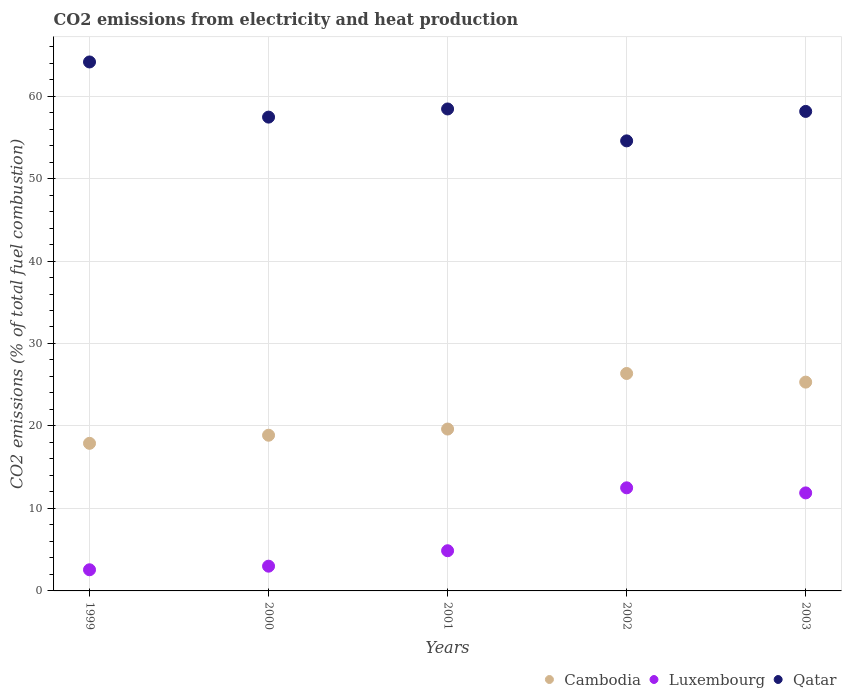How many different coloured dotlines are there?
Your answer should be compact. 3. Is the number of dotlines equal to the number of legend labels?
Offer a terse response. Yes. What is the amount of CO2 emitted in Luxembourg in 2000?
Your answer should be very brief. 3. Across all years, what is the maximum amount of CO2 emitted in Qatar?
Offer a terse response. 64.13. Across all years, what is the minimum amount of CO2 emitted in Cambodia?
Your answer should be very brief. 17.89. In which year was the amount of CO2 emitted in Luxembourg minimum?
Ensure brevity in your answer.  1999. What is the total amount of CO2 emitted in Luxembourg in the graph?
Your answer should be compact. 34.82. What is the difference between the amount of CO2 emitted in Cambodia in 1999 and that in 2000?
Provide a succinct answer. -0.98. What is the difference between the amount of CO2 emitted in Qatar in 2002 and the amount of CO2 emitted in Luxembourg in 2003?
Provide a succinct answer. 42.68. What is the average amount of CO2 emitted in Cambodia per year?
Offer a very short reply. 21.62. In the year 2002, what is the difference between the amount of CO2 emitted in Luxembourg and amount of CO2 emitted in Qatar?
Your response must be concise. -42.07. In how many years, is the amount of CO2 emitted in Cambodia greater than 2 %?
Offer a very short reply. 5. What is the ratio of the amount of CO2 emitted in Qatar in 2001 to that in 2002?
Your response must be concise. 1.07. Is the amount of CO2 emitted in Cambodia in 2001 less than that in 2002?
Your answer should be very brief. Yes. What is the difference between the highest and the second highest amount of CO2 emitted in Cambodia?
Keep it short and to the point. 1.05. What is the difference between the highest and the lowest amount of CO2 emitted in Cambodia?
Make the answer very short. 8.47. Is the amount of CO2 emitted in Luxembourg strictly greater than the amount of CO2 emitted in Cambodia over the years?
Ensure brevity in your answer.  No. How many dotlines are there?
Make the answer very short. 3. What is the difference between two consecutive major ticks on the Y-axis?
Provide a short and direct response. 10. Are the values on the major ticks of Y-axis written in scientific E-notation?
Keep it short and to the point. No. What is the title of the graph?
Give a very brief answer. CO2 emissions from electricity and heat production. Does "Upper middle income" appear as one of the legend labels in the graph?
Make the answer very short. No. What is the label or title of the Y-axis?
Offer a terse response. CO2 emissions (% of total fuel combustion). What is the CO2 emissions (% of total fuel combustion) in Cambodia in 1999?
Offer a very short reply. 17.89. What is the CO2 emissions (% of total fuel combustion) in Luxembourg in 1999?
Your answer should be very brief. 2.56. What is the CO2 emissions (% of total fuel combustion) in Qatar in 1999?
Offer a terse response. 64.13. What is the CO2 emissions (% of total fuel combustion) of Cambodia in 2000?
Your answer should be compact. 18.88. What is the CO2 emissions (% of total fuel combustion) of Qatar in 2000?
Ensure brevity in your answer.  57.45. What is the CO2 emissions (% of total fuel combustion) in Cambodia in 2001?
Keep it short and to the point. 19.63. What is the CO2 emissions (% of total fuel combustion) in Luxembourg in 2001?
Provide a succinct answer. 4.87. What is the CO2 emissions (% of total fuel combustion) of Qatar in 2001?
Provide a short and direct response. 58.44. What is the CO2 emissions (% of total fuel combustion) of Cambodia in 2002?
Your response must be concise. 26.36. What is the CO2 emissions (% of total fuel combustion) of Luxembourg in 2002?
Ensure brevity in your answer.  12.5. What is the CO2 emissions (% of total fuel combustion) of Qatar in 2002?
Keep it short and to the point. 54.57. What is the CO2 emissions (% of total fuel combustion) in Cambodia in 2003?
Your answer should be very brief. 25.32. What is the CO2 emissions (% of total fuel combustion) in Luxembourg in 2003?
Ensure brevity in your answer.  11.89. What is the CO2 emissions (% of total fuel combustion) of Qatar in 2003?
Offer a very short reply. 58.14. Across all years, what is the maximum CO2 emissions (% of total fuel combustion) in Cambodia?
Make the answer very short. 26.36. Across all years, what is the maximum CO2 emissions (% of total fuel combustion) in Luxembourg?
Offer a very short reply. 12.5. Across all years, what is the maximum CO2 emissions (% of total fuel combustion) of Qatar?
Provide a succinct answer. 64.13. Across all years, what is the minimum CO2 emissions (% of total fuel combustion) of Cambodia?
Offer a terse response. 17.89. Across all years, what is the minimum CO2 emissions (% of total fuel combustion) of Luxembourg?
Make the answer very short. 2.56. Across all years, what is the minimum CO2 emissions (% of total fuel combustion) of Qatar?
Offer a very short reply. 54.57. What is the total CO2 emissions (% of total fuel combustion) in Cambodia in the graph?
Provide a succinct answer. 108.08. What is the total CO2 emissions (% of total fuel combustion) of Luxembourg in the graph?
Provide a succinct answer. 34.82. What is the total CO2 emissions (% of total fuel combustion) in Qatar in the graph?
Provide a succinct answer. 292.72. What is the difference between the CO2 emissions (% of total fuel combustion) in Cambodia in 1999 and that in 2000?
Provide a short and direct response. -0.98. What is the difference between the CO2 emissions (% of total fuel combustion) of Luxembourg in 1999 and that in 2000?
Offer a very short reply. -0.44. What is the difference between the CO2 emissions (% of total fuel combustion) of Qatar in 1999 and that in 2000?
Your answer should be very brief. 6.69. What is the difference between the CO2 emissions (% of total fuel combustion) in Cambodia in 1999 and that in 2001?
Your answer should be very brief. -1.73. What is the difference between the CO2 emissions (% of total fuel combustion) in Luxembourg in 1999 and that in 2001?
Your response must be concise. -2.31. What is the difference between the CO2 emissions (% of total fuel combustion) in Qatar in 1999 and that in 2001?
Provide a short and direct response. 5.7. What is the difference between the CO2 emissions (% of total fuel combustion) of Cambodia in 1999 and that in 2002?
Make the answer very short. -8.47. What is the difference between the CO2 emissions (% of total fuel combustion) in Luxembourg in 1999 and that in 2002?
Offer a very short reply. -9.94. What is the difference between the CO2 emissions (% of total fuel combustion) of Qatar in 1999 and that in 2002?
Offer a very short reply. 9.57. What is the difference between the CO2 emissions (% of total fuel combustion) in Cambodia in 1999 and that in 2003?
Keep it short and to the point. -7.42. What is the difference between the CO2 emissions (% of total fuel combustion) in Luxembourg in 1999 and that in 2003?
Ensure brevity in your answer.  -9.32. What is the difference between the CO2 emissions (% of total fuel combustion) of Qatar in 1999 and that in 2003?
Your response must be concise. 6. What is the difference between the CO2 emissions (% of total fuel combustion) in Cambodia in 2000 and that in 2001?
Your answer should be very brief. -0.75. What is the difference between the CO2 emissions (% of total fuel combustion) of Luxembourg in 2000 and that in 2001?
Give a very brief answer. -1.87. What is the difference between the CO2 emissions (% of total fuel combustion) in Qatar in 2000 and that in 2001?
Your answer should be compact. -0.99. What is the difference between the CO2 emissions (% of total fuel combustion) of Cambodia in 2000 and that in 2002?
Provide a short and direct response. -7.49. What is the difference between the CO2 emissions (% of total fuel combustion) in Luxembourg in 2000 and that in 2002?
Your response must be concise. -9.5. What is the difference between the CO2 emissions (% of total fuel combustion) in Qatar in 2000 and that in 2002?
Your answer should be very brief. 2.88. What is the difference between the CO2 emissions (% of total fuel combustion) in Cambodia in 2000 and that in 2003?
Offer a terse response. -6.44. What is the difference between the CO2 emissions (% of total fuel combustion) in Luxembourg in 2000 and that in 2003?
Offer a terse response. -8.89. What is the difference between the CO2 emissions (% of total fuel combustion) in Qatar in 2000 and that in 2003?
Provide a short and direct response. -0.69. What is the difference between the CO2 emissions (% of total fuel combustion) of Cambodia in 2001 and that in 2002?
Your response must be concise. -6.74. What is the difference between the CO2 emissions (% of total fuel combustion) of Luxembourg in 2001 and that in 2002?
Give a very brief answer. -7.63. What is the difference between the CO2 emissions (% of total fuel combustion) of Qatar in 2001 and that in 2002?
Ensure brevity in your answer.  3.87. What is the difference between the CO2 emissions (% of total fuel combustion) in Cambodia in 2001 and that in 2003?
Keep it short and to the point. -5.69. What is the difference between the CO2 emissions (% of total fuel combustion) in Luxembourg in 2001 and that in 2003?
Offer a very short reply. -7.01. What is the difference between the CO2 emissions (% of total fuel combustion) of Qatar in 2001 and that in 2003?
Give a very brief answer. 0.3. What is the difference between the CO2 emissions (% of total fuel combustion) in Cambodia in 2002 and that in 2003?
Provide a succinct answer. 1.05. What is the difference between the CO2 emissions (% of total fuel combustion) of Luxembourg in 2002 and that in 2003?
Give a very brief answer. 0.61. What is the difference between the CO2 emissions (% of total fuel combustion) of Qatar in 2002 and that in 2003?
Provide a short and direct response. -3.57. What is the difference between the CO2 emissions (% of total fuel combustion) in Cambodia in 1999 and the CO2 emissions (% of total fuel combustion) in Luxembourg in 2000?
Provide a short and direct response. 14.89. What is the difference between the CO2 emissions (% of total fuel combustion) in Cambodia in 1999 and the CO2 emissions (% of total fuel combustion) in Qatar in 2000?
Offer a terse response. -39.55. What is the difference between the CO2 emissions (% of total fuel combustion) in Luxembourg in 1999 and the CO2 emissions (% of total fuel combustion) in Qatar in 2000?
Provide a short and direct response. -54.88. What is the difference between the CO2 emissions (% of total fuel combustion) in Cambodia in 1999 and the CO2 emissions (% of total fuel combustion) in Luxembourg in 2001?
Keep it short and to the point. 13.02. What is the difference between the CO2 emissions (% of total fuel combustion) of Cambodia in 1999 and the CO2 emissions (% of total fuel combustion) of Qatar in 2001?
Provide a short and direct response. -40.54. What is the difference between the CO2 emissions (% of total fuel combustion) of Luxembourg in 1999 and the CO2 emissions (% of total fuel combustion) of Qatar in 2001?
Provide a short and direct response. -55.87. What is the difference between the CO2 emissions (% of total fuel combustion) of Cambodia in 1999 and the CO2 emissions (% of total fuel combustion) of Luxembourg in 2002?
Give a very brief answer. 5.39. What is the difference between the CO2 emissions (% of total fuel combustion) of Cambodia in 1999 and the CO2 emissions (% of total fuel combustion) of Qatar in 2002?
Your answer should be compact. -36.67. What is the difference between the CO2 emissions (% of total fuel combustion) of Luxembourg in 1999 and the CO2 emissions (% of total fuel combustion) of Qatar in 2002?
Provide a short and direct response. -52. What is the difference between the CO2 emissions (% of total fuel combustion) in Cambodia in 1999 and the CO2 emissions (% of total fuel combustion) in Luxembourg in 2003?
Offer a very short reply. 6.01. What is the difference between the CO2 emissions (% of total fuel combustion) of Cambodia in 1999 and the CO2 emissions (% of total fuel combustion) of Qatar in 2003?
Your response must be concise. -40.24. What is the difference between the CO2 emissions (% of total fuel combustion) in Luxembourg in 1999 and the CO2 emissions (% of total fuel combustion) in Qatar in 2003?
Offer a very short reply. -55.57. What is the difference between the CO2 emissions (% of total fuel combustion) of Cambodia in 2000 and the CO2 emissions (% of total fuel combustion) of Luxembourg in 2001?
Ensure brevity in your answer.  14.01. What is the difference between the CO2 emissions (% of total fuel combustion) in Cambodia in 2000 and the CO2 emissions (% of total fuel combustion) in Qatar in 2001?
Your answer should be very brief. -39.56. What is the difference between the CO2 emissions (% of total fuel combustion) in Luxembourg in 2000 and the CO2 emissions (% of total fuel combustion) in Qatar in 2001?
Your response must be concise. -55.44. What is the difference between the CO2 emissions (% of total fuel combustion) of Cambodia in 2000 and the CO2 emissions (% of total fuel combustion) of Luxembourg in 2002?
Your response must be concise. 6.38. What is the difference between the CO2 emissions (% of total fuel combustion) in Cambodia in 2000 and the CO2 emissions (% of total fuel combustion) in Qatar in 2002?
Your answer should be compact. -35.69. What is the difference between the CO2 emissions (% of total fuel combustion) of Luxembourg in 2000 and the CO2 emissions (% of total fuel combustion) of Qatar in 2002?
Your answer should be very brief. -51.57. What is the difference between the CO2 emissions (% of total fuel combustion) of Cambodia in 2000 and the CO2 emissions (% of total fuel combustion) of Luxembourg in 2003?
Your response must be concise. 6.99. What is the difference between the CO2 emissions (% of total fuel combustion) in Cambodia in 2000 and the CO2 emissions (% of total fuel combustion) in Qatar in 2003?
Give a very brief answer. -39.26. What is the difference between the CO2 emissions (% of total fuel combustion) in Luxembourg in 2000 and the CO2 emissions (% of total fuel combustion) in Qatar in 2003?
Your answer should be very brief. -55.14. What is the difference between the CO2 emissions (% of total fuel combustion) of Cambodia in 2001 and the CO2 emissions (% of total fuel combustion) of Luxembourg in 2002?
Provide a short and direct response. 7.13. What is the difference between the CO2 emissions (% of total fuel combustion) of Cambodia in 2001 and the CO2 emissions (% of total fuel combustion) of Qatar in 2002?
Keep it short and to the point. -34.94. What is the difference between the CO2 emissions (% of total fuel combustion) in Luxembourg in 2001 and the CO2 emissions (% of total fuel combustion) in Qatar in 2002?
Your answer should be very brief. -49.69. What is the difference between the CO2 emissions (% of total fuel combustion) of Cambodia in 2001 and the CO2 emissions (% of total fuel combustion) of Luxembourg in 2003?
Provide a succinct answer. 7.74. What is the difference between the CO2 emissions (% of total fuel combustion) in Cambodia in 2001 and the CO2 emissions (% of total fuel combustion) in Qatar in 2003?
Ensure brevity in your answer.  -38.51. What is the difference between the CO2 emissions (% of total fuel combustion) in Luxembourg in 2001 and the CO2 emissions (% of total fuel combustion) in Qatar in 2003?
Ensure brevity in your answer.  -53.27. What is the difference between the CO2 emissions (% of total fuel combustion) in Cambodia in 2002 and the CO2 emissions (% of total fuel combustion) in Luxembourg in 2003?
Provide a succinct answer. 14.48. What is the difference between the CO2 emissions (% of total fuel combustion) in Cambodia in 2002 and the CO2 emissions (% of total fuel combustion) in Qatar in 2003?
Make the answer very short. -31.77. What is the difference between the CO2 emissions (% of total fuel combustion) of Luxembourg in 2002 and the CO2 emissions (% of total fuel combustion) of Qatar in 2003?
Offer a terse response. -45.64. What is the average CO2 emissions (% of total fuel combustion) in Cambodia per year?
Your response must be concise. 21.62. What is the average CO2 emissions (% of total fuel combustion) of Luxembourg per year?
Keep it short and to the point. 6.96. What is the average CO2 emissions (% of total fuel combustion) in Qatar per year?
Your answer should be compact. 58.54. In the year 1999, what is the difference between the CO2 emissions (% of total fuel combustion) in Cambodia and CO2 emissions (% of total fuel combustion) in Luxembourg?
Offer a terse response. 15.33. In the year 1999, what is the difference between the CO2 emissions (% of total fuel combustion) in Cambodia and CO2 emissions (% of total fuel combustion) in Qatar?
Your response must be concise. -46.24. In the year 1999, what is the difference between the CO2 emissions (% of total fuel combustion) in Luxembourg and CO2 emissions (% of total fuel combustion) in Qatar?
Offer a terse response. -61.57. In the year 2000, what is the difference between the CO2 emissions (% of total fuel combustion) in Cambodia and CO2 emissions (% of total fuel combustion) in Luxembourg?
Make the answer very short. 15.88. In the year 2000, what is the difference between the CO2 emissions (% of total fuel combustion) in Cambodia and CO2 emissions (% of total fuel combustion) in Qatar?
Ensure brevity in your answer.  -38.57. In the year 2000, what is the difference between the CO2 emissions (% of total fuel combustion) in Luxembourg and CO2 emissions (% of total fuel combustion) in Qatar?
Provide a short and direct response. -54.45. In the year 2001, what is the difference between the CO2 emissions (% of total fuel combustion) in Cambodia and CO2 emissions (% of total fuel combustion) in Luxembourg?
Ensure brevity in your answer.  14.75. In the year 2001, what is the difference between the CO2 emissions (% of total fuel combustion) of Cambodia and CO2 emissions (% of total fuel combustion) of Qatar?
Offer a terse response. -38.81. In the year 2001, what is the difference between the CO2 emissions (% of total fuel combustion) in Luxembourg and CO2 emissions (% of total fuel combustion) in Qatar?
Give a very brief answer. -53.56. In the year 2002, what is the difference between the CO2 emissions (% of total fuel combustion) of Cambodia and CO2 emissions (% of total fuel combustion) of Luxembourg?
Your response must be concise. 13.86. In the year 2002, what is the difference between the CO2 emissions (% of total fuel combustion) in Cambodia and CO2 emissions (% of total fuel combustion) in Qatar?
Your answer should be compact. -28.2. In the year 2002, what is the difference between the CO2 emissions (% of total fuel combustion) of Luxembourg and CO2 emissions (% of total fuel combustion) of Qatar?
Offer a very short reply. -42.07. In the year 2003, what is the difference between the CO2 emissions (% of total fuel combustion) in Cambodia and CO2 emissions (% of total fuel combustion) in Luxembourg?
Keep it short and to the point. 13.43. In the year 2003, what is the difference between the CO2 emissions (% of total fuel combustion) of Cambodia and CO2 emissions (% of total fuel combustion) of Qatar?
Offer a terse response. -32.82. In the year 2003, what is the difference between the CO2 emissions (% of total fuel combustion) of Luxembourg and CO2 emissions (% of total fuel combustion) of Qatar?
Offer a very short reply. -46.25. What is the ratio of the CO2 emissions (% of total fuel combustion) of Cambodia in 1999 to that in 2000?
Your answer should be very brief. 0.95. What is the ratio of the CO2 emissions (% of total fuel combustion) in Luxembourg in 1999 to that in 2000?
Give a very brief answer. 0.85. What is the ratio of the CO2 emissions (% of total fuel combustion) in Qatar in 1999 to that in 2000?
Give a very brief answer. 1.12. What is the ratio of the CO2 emissions (% of total fuel combustion) of Cambodia in 1999 to that in 2001?
Your response must be concise. 0.91. What is the ratio of the CO2 emissions (% of total fuel combustion) in Luxembourg in 1999 to that in 2001?
Offer a very short reply. 0.53. What is the ratio of the CO2 emissions (% of total fuel combustion) in Qatar in 1999 to that in 2001?
Provide a succinct answer. 1.1. What is the ratio of the CO2 emissions (% of total fuel combustion) in Cambodia in 1999 to that in 2002?
Ensure brevity in your answer.  0.68. What is the ratio of the CO2 emissions (% of total fuel combustion) of Luxembourg in 1999 to that in 2002?
Ensure brevity in your answer.  0.21. What is the ratio of the CO2 emissions (% of total fuel combustion) in Qatar in 1999 to that in 2002?
Your response must be concise. 1.18. What is the ratio of the CO2 emissions (% of total fuel combustion) of Cambodia in 1999 to that in 2003?
Make the answer very short. 0.71. What is the ratio of the CO2 emissions (% of total fuel combustion) in Luxembourg in 1999 to that in 2003?
Ensure brevity in your answer.  0.22. What is the ratio of the CO2 emissions (% of total fuel combustion) of Qatar in 1999 to that in 2003?
Ensure brevity in your answer.  1.1. What is the ratio of the CO2 emissions (% of total fuel combustion) in Cambodia in 2000 to that in 2001?
Your response must be concise. 0.96. What is the ratio of the CO2 emissions (% of total fuel combustion) in Luxembourg in 2000 to that in 2001?
Make the answer very short. 0.62. What is the ratio of the CO2 emissions (% of total fuel combustion) of Qatar in 2000 to that in 2001?
Offer a very short reply. 0.98. What is the ratio of the CO2 emissions (% of total fuel combustion) of Cambodia in 2000 to that in 2002?
Keep it short and to the point. 0.72. What is the ratio of the CO2 emissions (% of total fuel combustion) in Luxembourg in 2000 to that in 2002?
Provide a succinct answer. 0.24. What is the ratio of the CO2 emissions (% of total fuel combustion) of Qatar in 2000 to that in 2002?
Your response must be concise. 1.05. What is the ratio of the CO2 emissions (% of total fuel combustion) in Cambodia in 2000 to that in 2003?
Provide a succinct answer. 0.75. What is the ratio of the CO2 emissions (% of total fuel combustion) of Luxembourg in 2000 to that in 2003?
Ensure brevity in your answer.  0.25. What is the ratio of the CO2 emissions (% of total fuel combustion) of Qatar in 2000 to that in 2003?
Offer a terse response. 0.99. What is the ratio of the CO2 emissions (% of total fuel combustion) of Cambodia in 2001 to that in 2002?
Keep it short and to the point. 0.74. What is the ratio of the CO2 emissions (% of total fuel combustion) in Luxembourg in 2001 to that in 2002?
Ensure brevity in your answer.  0.39. What is the ratio of the CO2 emissions (% of total fuel combustion) of Qatar in 2001 to that in 2002?
Provide a short and direct response. 1.07. What is the ratio of the CO2 emissions (% of total fuel combustion) of Cambodia in 2001 to that in 2003?
Your answer should be very brief. 0.78. What is the ratio of the CO2 emissions (% of total fuel combustion) of Luxembourg in 2001 to that in 2003?
Provide a short and direct response. 0.41. What is the ratio of the CO2 emissions (% of total fuel combustion) of Qatar in 2001 to that in 2003?
Your response must be concise. 1.01. What is the ratio of the CO2 emissions (% of total fuel combustion) in Cambodia in 2002 to that in 2003?
Your response must be concise. 1.04. What is the ratio of the CO2 emissions (% of total fuel combustion) in Luxembourg in 2002 to that in 2003?
Your answer should be compact. 1.05. What is the ratio of the CO2 emissions (% of total fuel combustion) of Qatar in 2002 to that in 2003?
Provide a succinct answer. 0.94. What is the difference between the highest and the second highest CO2 emissions (% of total fuel combustion) in Cambodia?
Give a very brief answer. 1.05. What is the difference between the highest and the second highest CO2 emissions (% of total fuel combustion) of Luxembourg?
Offer a very short reply. 0.61. What is the difference between the highest and the second highest CO2 emissions (% of total fuel combustion) of Qatar?
Offer a very short reply. 5.7. What is the difference between the highest and the lowest CO2 emissions (% of total fuel combustion) in Cambodia?
Your answer should be very brief. 8.47. What is the difference between the highest and the lowest CO2 emissions (% of total fuel combustion) in Luxembourg?
Offer a very short reply. 9.94. What is the difference between the highest and the lowest CO2 emissions (% of total fuel combustion) of Qatar?
Offer a terse response. 9.57. 